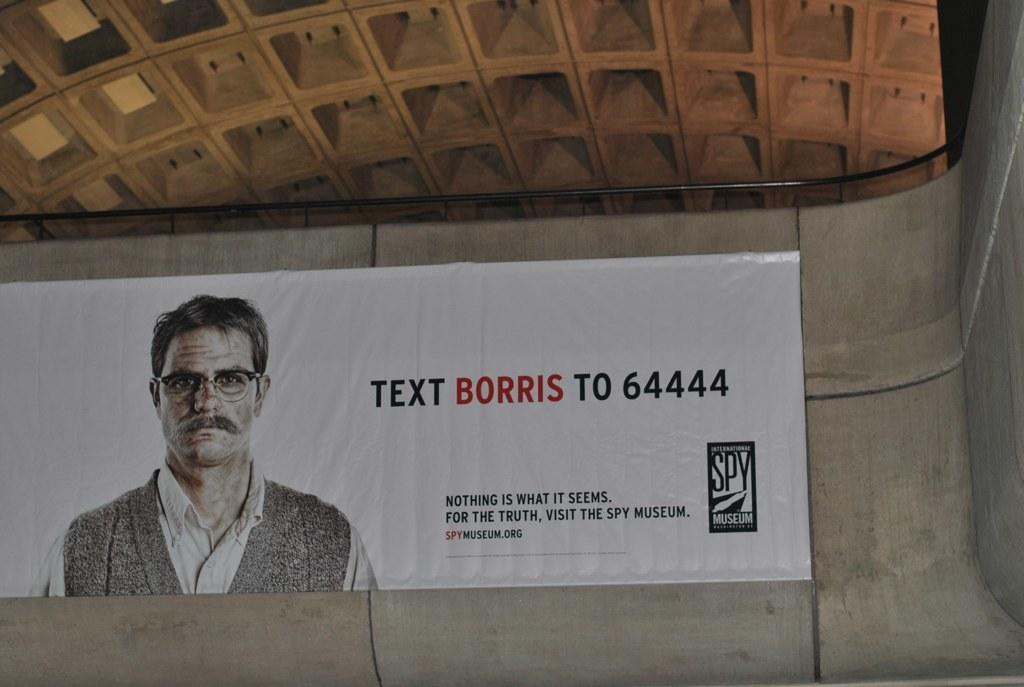What can be seen on the wall in the image? There is a banner on the wall in the image. What is depicted on the banner? There is a man depicted on the banner. What is the man wearing? The man is wearing a black jacket. What else is present on the banner besides the man? There is some matter written on the banner. Can you see the man's finger in the image? There is no finger visible in the image; the focus is on the banner and the man depicted on it. 